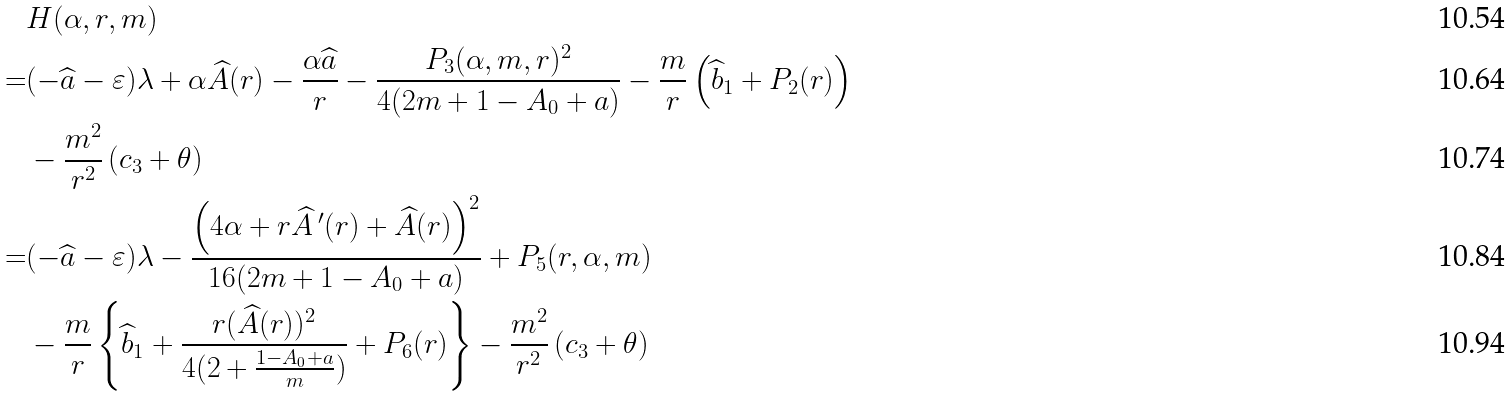Convert formula to latex. <formula><loc_0><loc_0><loc_500><loc_500>& H ( \alpha , r , m ) \\ = & ( - \widehat { a } - \varepsilon ) \lambda + \alpha \widehat { A } ( r ) - \frac { \alpha \widehat { a } } { r } - \frac { P _ { 3 } ( \alpha , m , r ) ^ { 2 } } { 4 ( 2 m + 1 - A _ { 0 } + a ) } - \frac { m } { r } \left ( \widehat { b } _ { 1 } + P _ { 2 } ( r ) \right ) \\ & - \frac { m ^ { 2 } } { r ^ { 2 } } \left ( c _ { 3 } + \theta \right ) \\ = & ( - \widehat { a } - \varepsilon ) \lambda - \frac { \left ( 4 \alpha + r \widehat { A } \, ^ { \prime } ( r ) + \widehat { A } ( r ) \right ) ^ { 2 } } { 1 6 ( 2 m + 1 - A _ { 0 } + a ) } + P _ { 5 } ( r , \alpha , m ) \\ & - \frac { m } { r } \left \{ \widehat { b } _ { 1 } + \frac { r ( \widehat { A } ( r ) ) ^ { 2 } } { 4 ( 2 + \frac { 1 - A _ { 0 } + a } { m } ) } + P _ { 6 } ( r ) \right \} - \frac { m ^ { 2 } } { r ^ { 2 } } \left ( c _ { 3 } + \theta \right )</formula> 